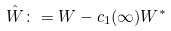<formula> <loc_0><loc_0><loc_500><loc_500>\hat { W } \colon = W - c _ { 1 } ( \infty ) W ^ { * }</formula> 